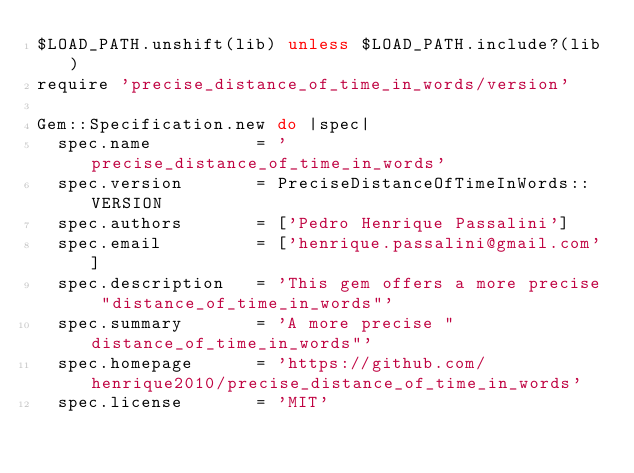Convert code to text. <code><loc_0><loc_0><loc_500><loc_500><_Ruby_>$LOAD_PATH.unshift(lib) unless $LOAD_PATH.include?(lib)
require 'precise_distance_of_time_in_words/version'

Gem::Specification.new do |spec|
  spec.name          = 'precise_distance_of_time_in_words'
  spec.version       = PreciseDistanceOfTimeInWords::VERSION
  spec.authors       = ['Pedro Henrique Passalini']
  spec.email         = ['henrique.passalini@gmail.com']
  spec.description   = 'This gem offers a more precise "distance_of_time_in_words"'
  spec.summary       = 'A more precise "distance_of_time_in_words"'
  spec.homepage      = 'https://github.com/henrique2010/precise_distance_of_time_in_words'
  spec.license       = 'MIT'
</code> 